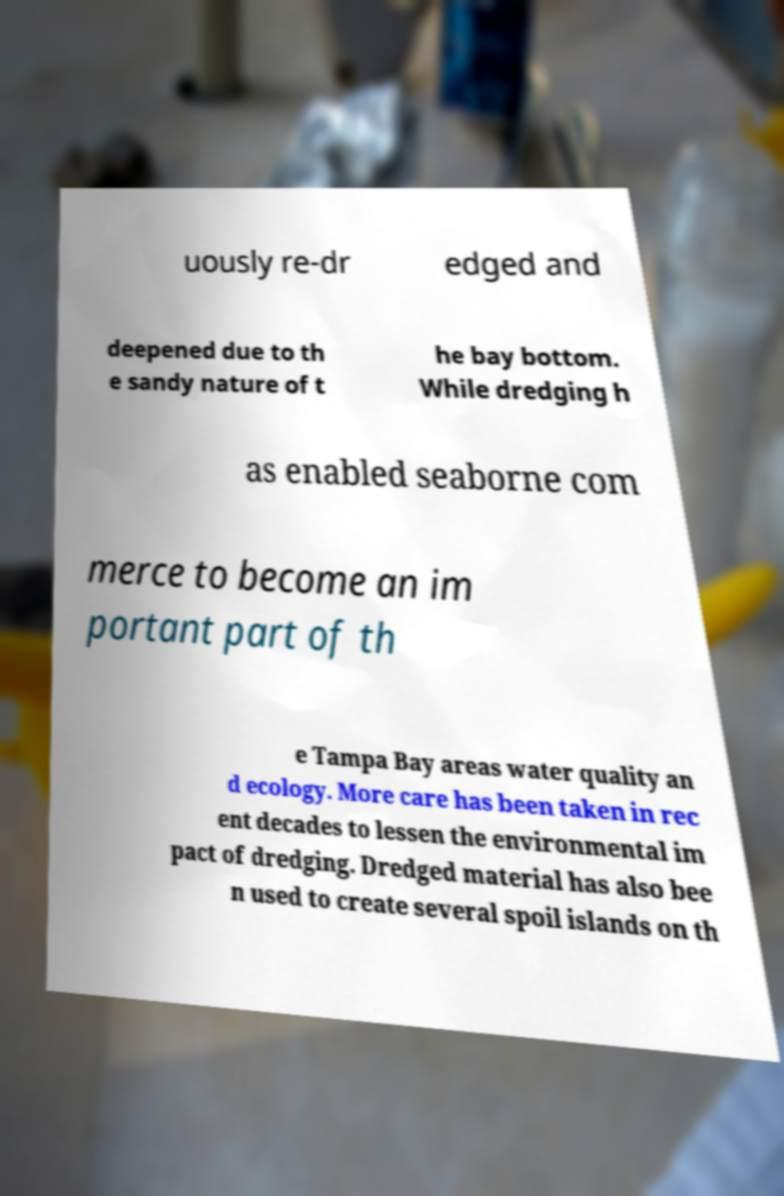There's text embedded in this image that I need extracted. Can you transcribe it verbatim? uously re-dr edged and deepened due to th e sandy nature of t he bay bottom. While dredging h as enabled seaborne com merce to become an im portant part of th e Tampa Bay areas water quality an d ecology. More care has been taken in rec ent decades to lessen the environmental im pact of dredging. Dredged material has also bee n used to create several spoil islands on th 